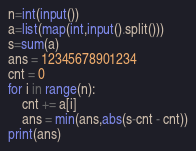Convert code to text. <code><loc_0><loc_0><loc_500><loc_500><_Python_>n=int(input())
a=list(map(int,input().split()))
s=sum(a)
ans = 12345678901234
cnt = 0
for i in range(n):
    cnt += a[i]
    ans = min(ans,abs(s-cnt - cnt))
print(ans)</code> 